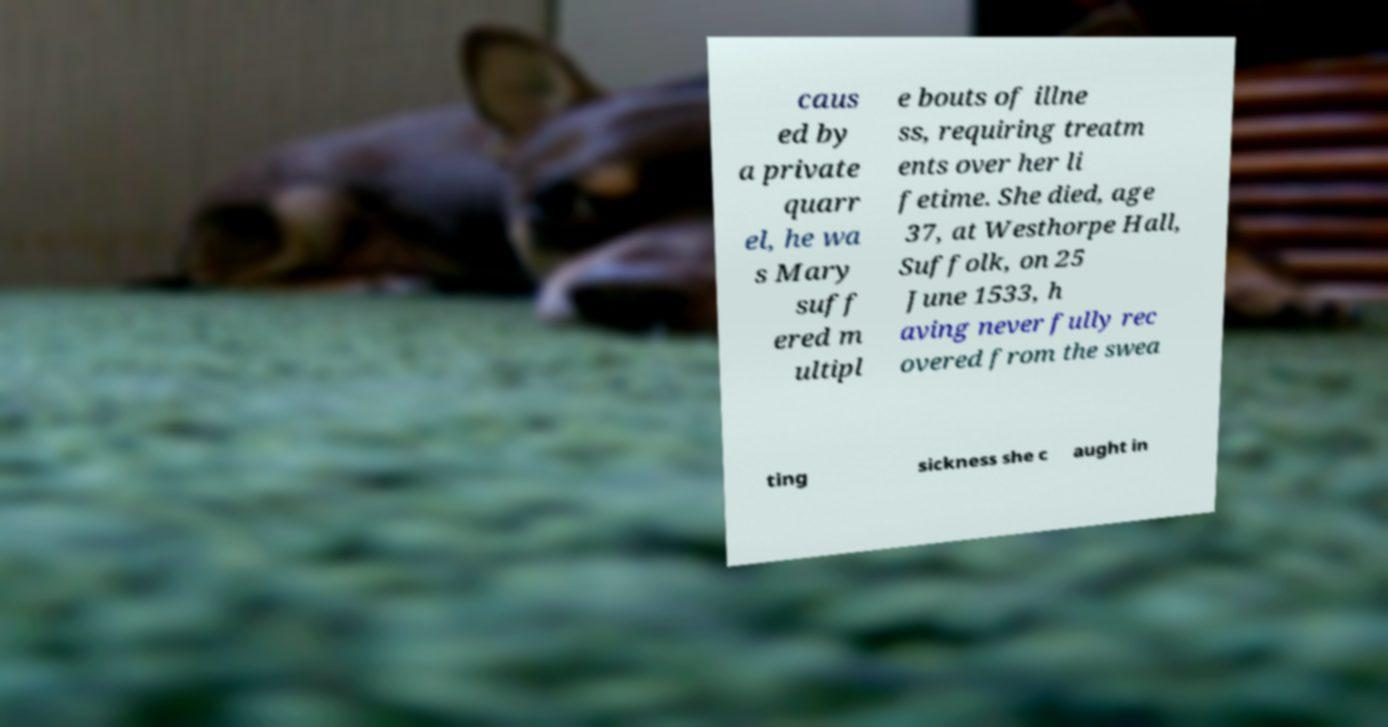I need the written content from this picture converted into text. Can you do that? caus ed by a private quarr el, he wa s Mary suff ered m ultipl e bouts of illne ss, requiring treatm ents over her li fetime. She died, age 37, at Westhorpe Hall, Suffolk, on 25 June 1533, h aving never fully rec overed from the swea ting sickness she c aught in 